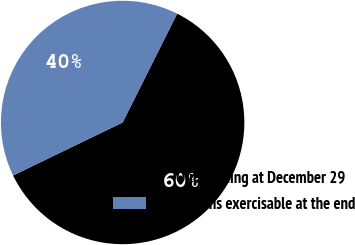<chart> <loc_0><loc_0><loc_500><loc_500><pie_chart><fcel>Outstanding at December 29<fcel>Options exercisable at the end<nl><fcel>60.44%<fcel>39.56%<nl></chart> 